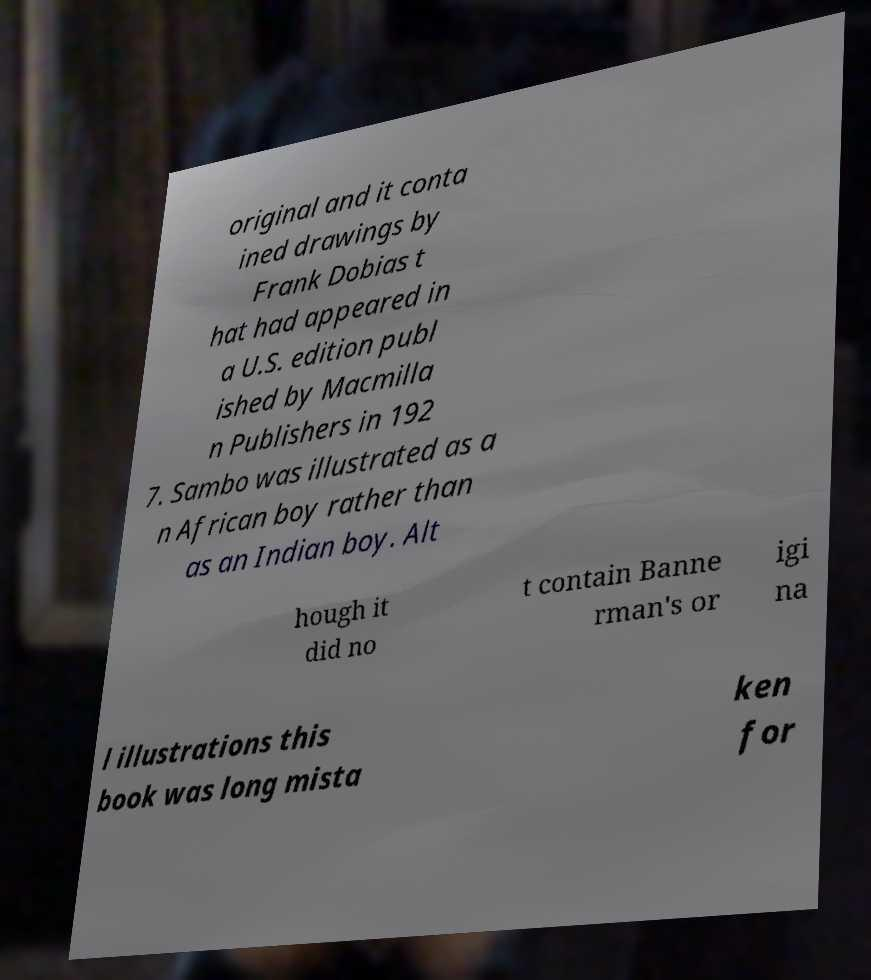Could you extract and type out the text from this image? original and it conta ined drawings by Frank Dobias t hat had appeared in a U.S. edition publ ished by Macmilla n Publishers in 192 7. Sambo was illustrated as a n African boy rather than as an Indian boy. Alt hough it did no t contain Banne rman's or igi na l illustrations this book was long mista ken for 